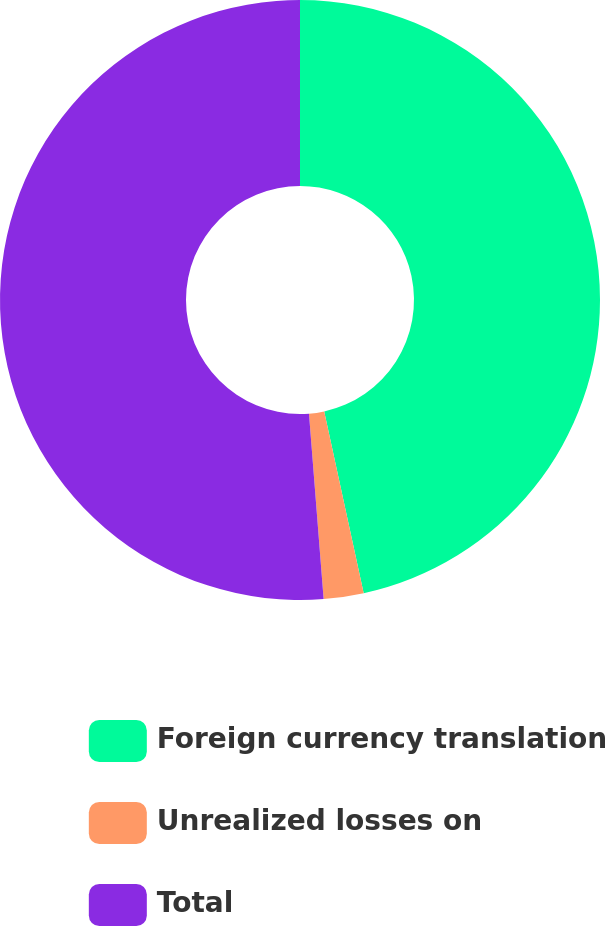Convert chart. <chart><loc_0><loc_0><loc_500><loc_500><pie_chart><fcel>Foreign currency translation<fcel>Unrealized losses on<fcel>Total<nl><fcel>46.59%<fcel>2.15%<fcel>51.25%<nl></chart> 